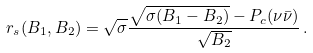Convert formula to latex. <formula><loc_0><loc_0><loc_500><loc_500>r _ { s } ( B _ { 1 } , B _ { 2 } ) = \sqrt { \sigma } { \frac { \sqrt { \sigma ( B _ { 1 } - B _ { 2 } ) } - P _ { c } ( \nu \bar { \nu } ) } { \sqrt { B _ { 2 } } } } \, .</formula> 